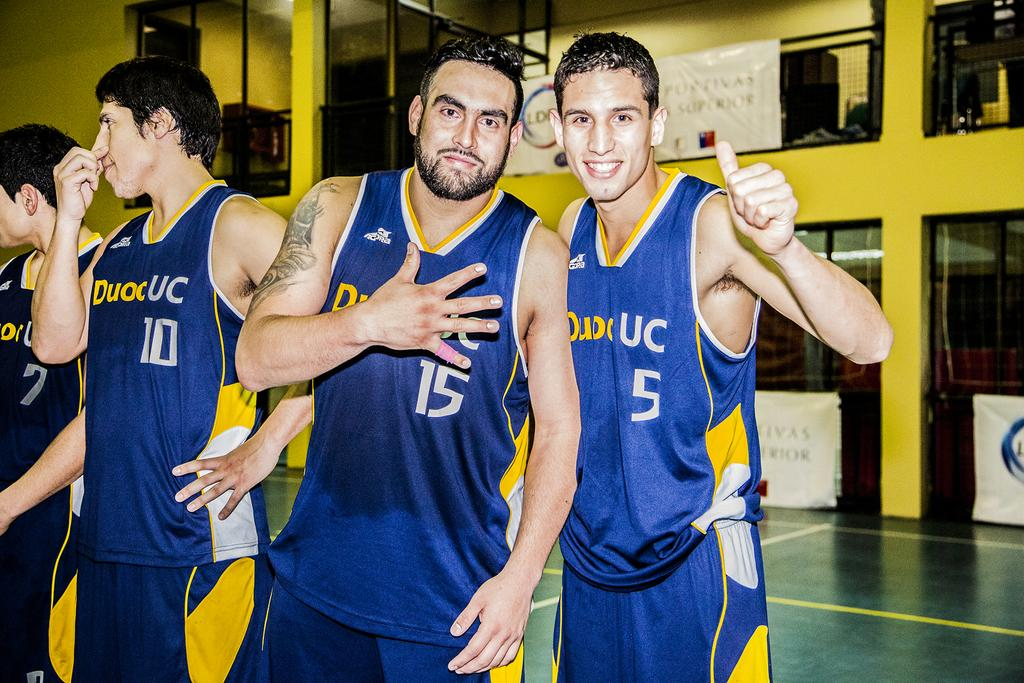<image>
Share a concise interpretation of the image provided. Players number 7, 10, 15 and 5 stand together on a basketball court. 